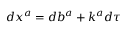<formula> <loc_0><loc_0><loc_500><loc_500>d x ^ { a } = d b ^ { a } + k ^ { a } d \tau</formula> 